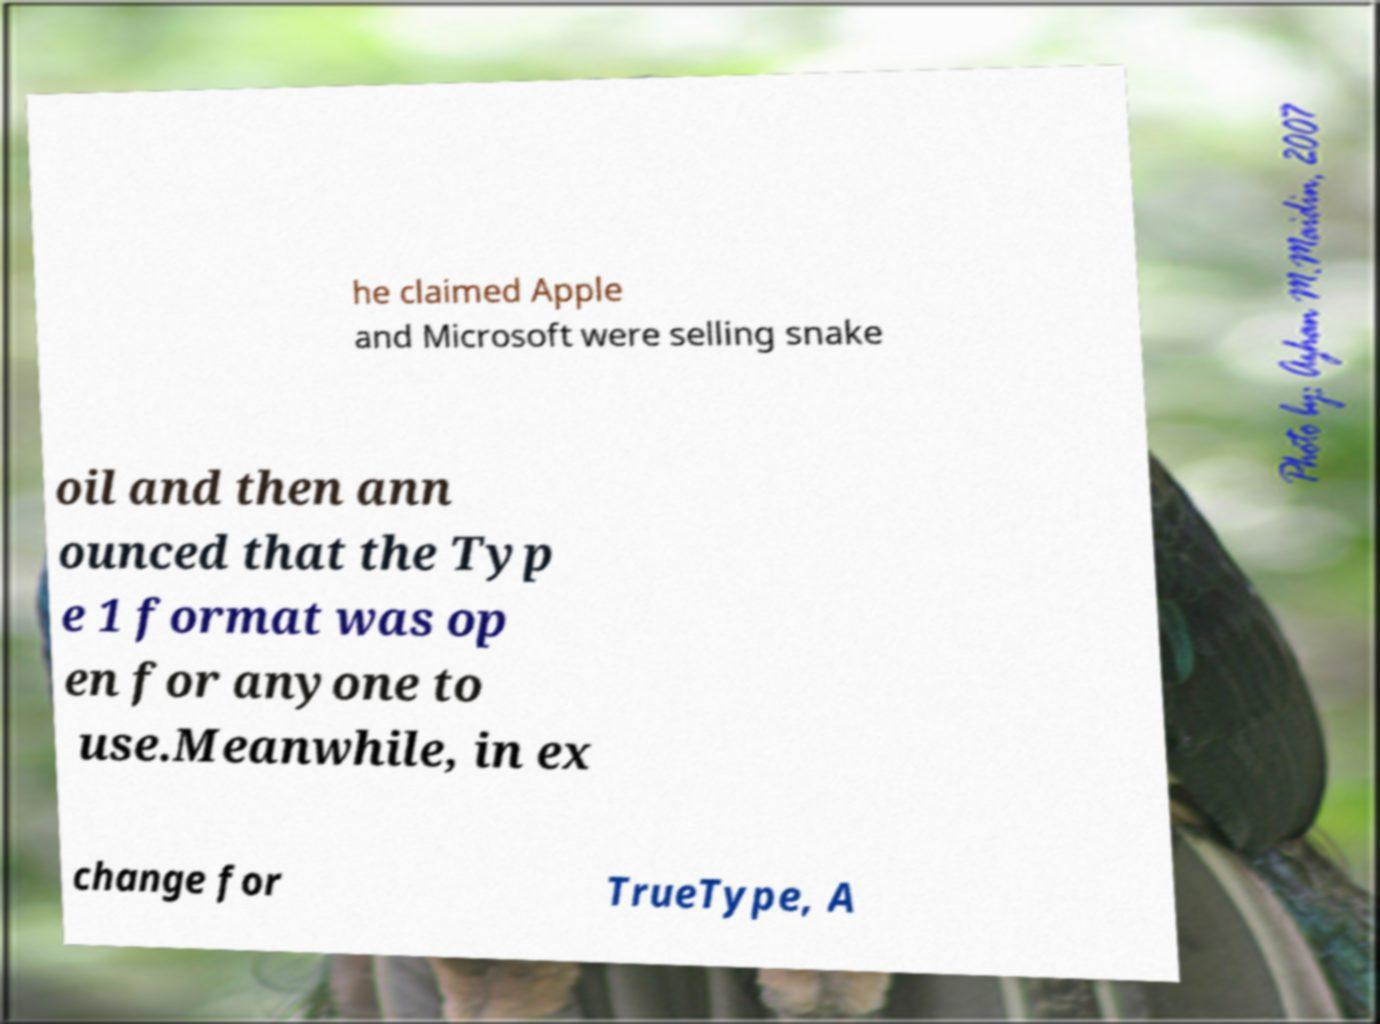I need the written content from this picture converted into text. Can you do that? he claimed Apple and Microsoft were selling snake oil and then ann ounced that the Typ e 1 format was op en for anyone to use.Meanwhile, in ex change for TrueType, A 